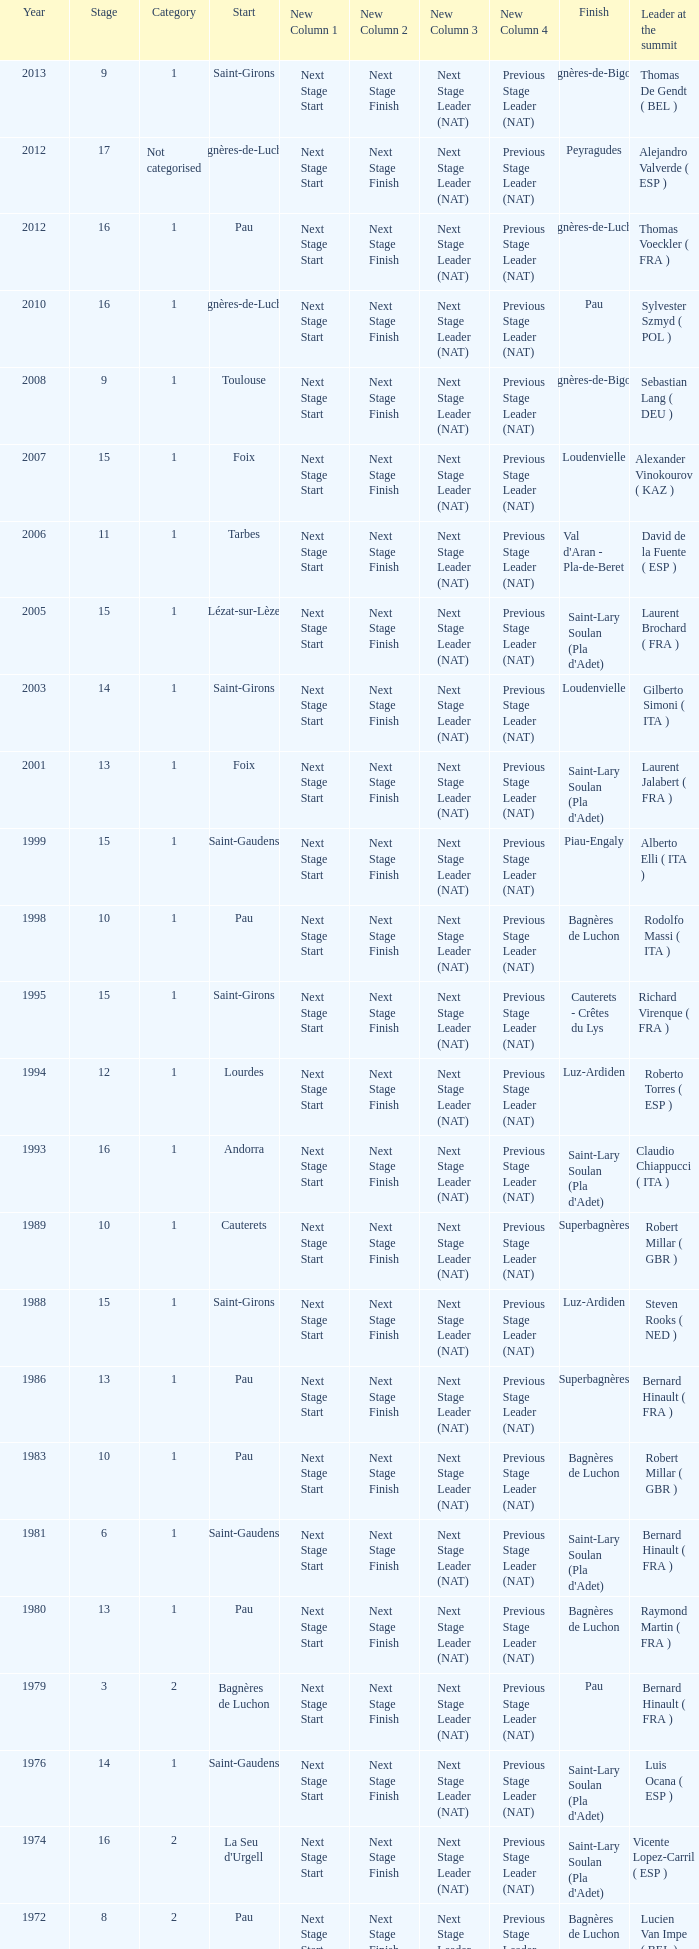What category was in 1964? 2.0. 